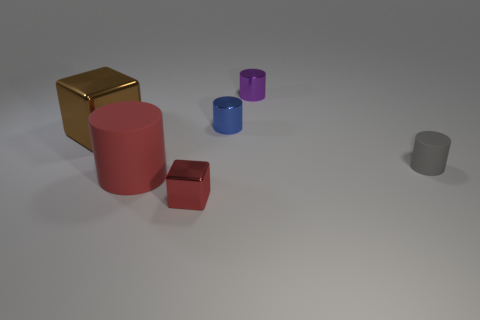Add 3 large red rubber cylinders. How many objects exist? 9 Subtract all blocks. How many objects are left? 4 Subtract 0 green spheres. How many objects are left? 6 Subtract all red cylinders. Subtract all tiny gray rubber cylinders. How many objects are left? 4 Add 6 rubber cylinders. How many rubber cylinders are left? 8 Add 4 big yellow metallic objects. How many big yellow metallic objects exist? 4 